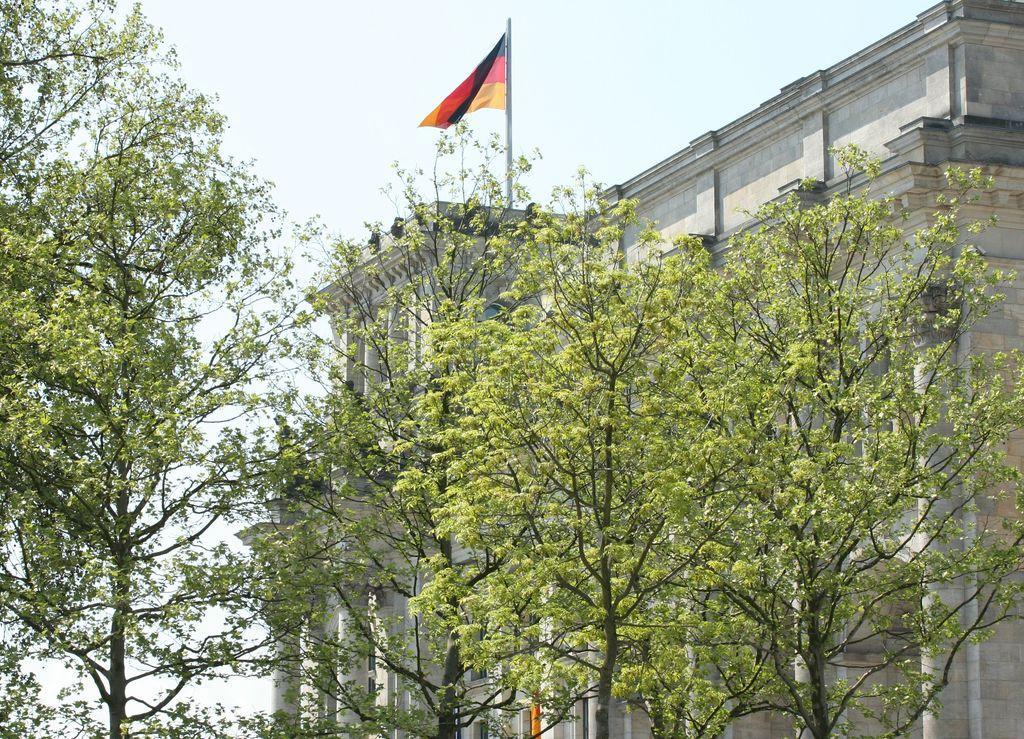How would you summarize this image in a sentence or two? In this image there are trees in the center. In the background there is a building and on the top of the building there is flag and the sky is cloudy. 